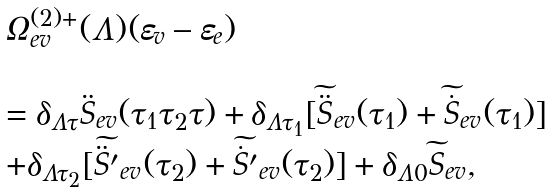<formula> <loc_0><loc_0><loc_500><loc_500>\begin{array} { l } \Omega _ { e v } ^ { ( 2 ) + } ( \Lambda ) ( \varepsilon _ { v } - \varepsilon _ { e } ) \\ \\ = \delta _ { \Lambda \tau } \ddot { S } _ { e v } ( \tau _ { 1 } \tau _ { 2 } \tau ) + \delta _ { \Lambda \tau _ { 1 } } [ \widetilde { \ddot { S } } _ { e v } ( \tau _ { 1 } ) + \widetilde { \dot { S } } _ { e v } ( \tau _ { 1 } ) ] \\ + \delta _ { \Lambda \tau _ { 2 } } [ \widetilde { \ddot { S } ^ { \prime } } _ { e v } ( \tau _ { 2 } ) + \widetilde { \dot { S } ^ { \prime } } _ { e v } ( \tau _ { 2 } ) ] + \delta _ { \Lambda 0 } \widetilde { S } _ { e v } , \end{array}</formula> 